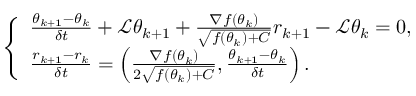<formula> <loc_0><loc_0><loc_500><loc_500>\left \{ \begin{array} { l l } { \frac { \theta _ { k + 1 } - \theta _ { k } } { \delta t } + \mathcal { L } \theta _ { k + 1 } + \frac { \nabla f ( \theta _ { k } ) } { \sqrt { f ( \theta _ { k } ) + C } } r _ { k + 1 } - \mathcal { L } \theta _ { k } = 0 , } \\ { \frac { r _ { k + 1 } - r _ { k } } { \delta t } = \left ( \frac { \nabla f ( \theta _ { k } ) } { 2 \sqrt { f ( \theta _ { k } ) + C } } , \frac { \theta _ { k + 1 } - \theta _ { k } } { \delta t } \right ) . } \end{array}</formula> 